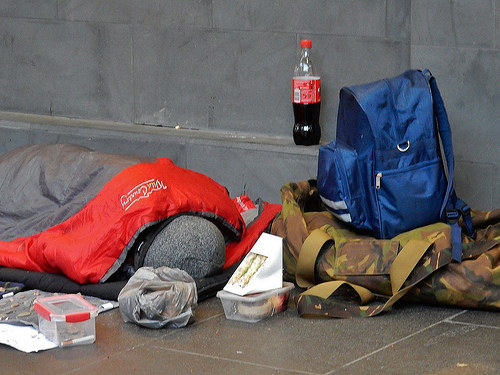<image>
Is the man on the sidewalk? Yes. Looking at the image, I can see the man is positioned on top of the sidewalk, with the sidewalk providing support. Is there a bottle in the bag? No. The bottle is not contained within the bag. These objects have a different spatial relationship. Where is the coke in relation to the backpack? Is it in front of the backpack? No. The coke is not in front of the backpack. The spatial positioning shows a different relationship between these objects. 